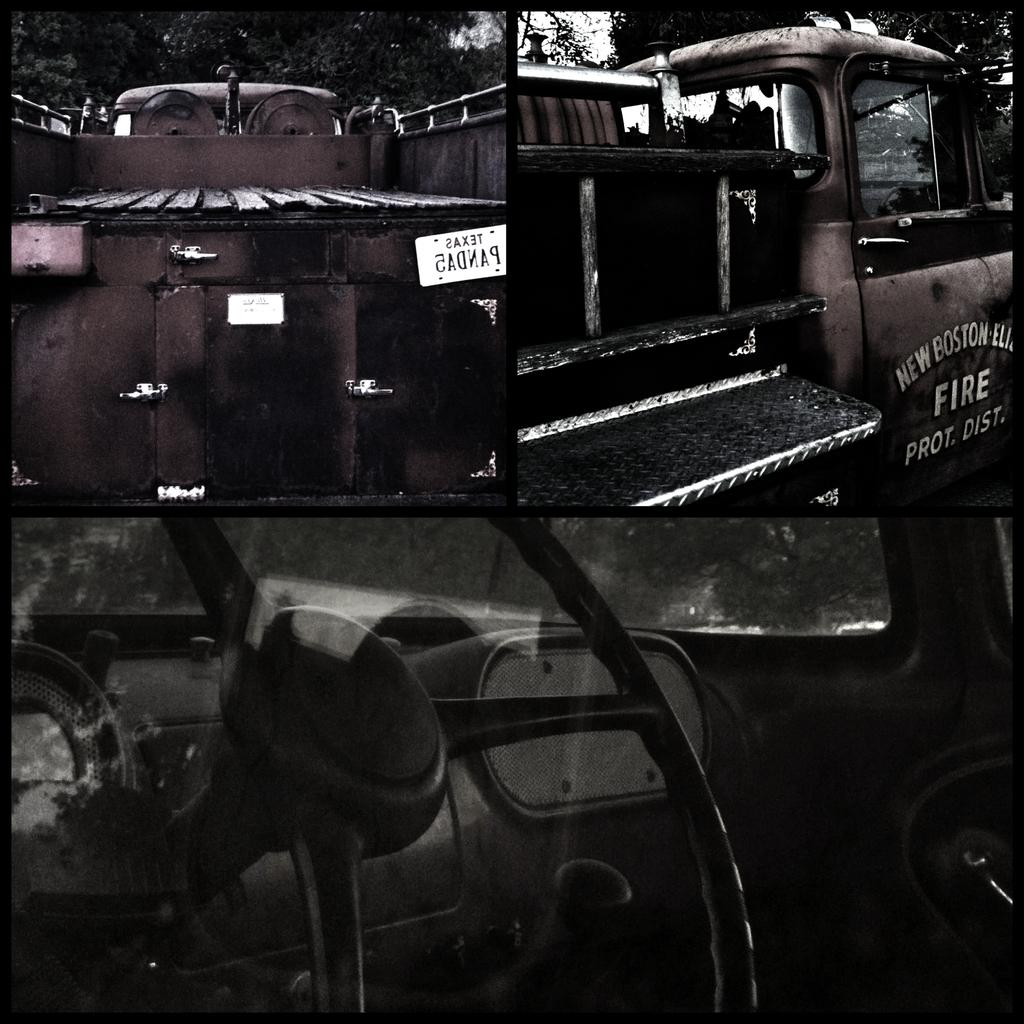What types of vehicles are in the front of the image? The specific types of vehicles are not mentioned, but there are vehicles in the front of the image. What can be seen in the background of the image? There are trees visible in the background of the image. What type of yam is being heard in the image? There is no yam or any audible element in the image, as it is a still image. 